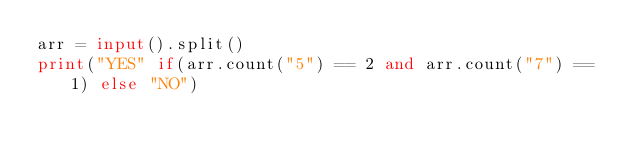<code> <loc_0><loc_0><loc_500><loc_500><_Python_>arr = input().split()
print("YES" if(arr.count("5") == 2 and arr.count("7") == 1) else "NO")
</code> 